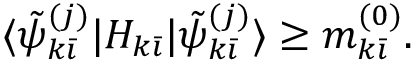Convert formula to latex. <formula><loc_0><loc_0><loc_500><loc_500>\langle \tilde { \psi } _ { k \bar { \imath } } ^ { ( j ) } | H _ { k \bar { \imath } } | \tilde { \psi } _ { k \bar { \imath } } ^ { ( j ) } \rangle \geq m _ { k \bar { \imath } } ^ { ( 0 ) } .</formula> 